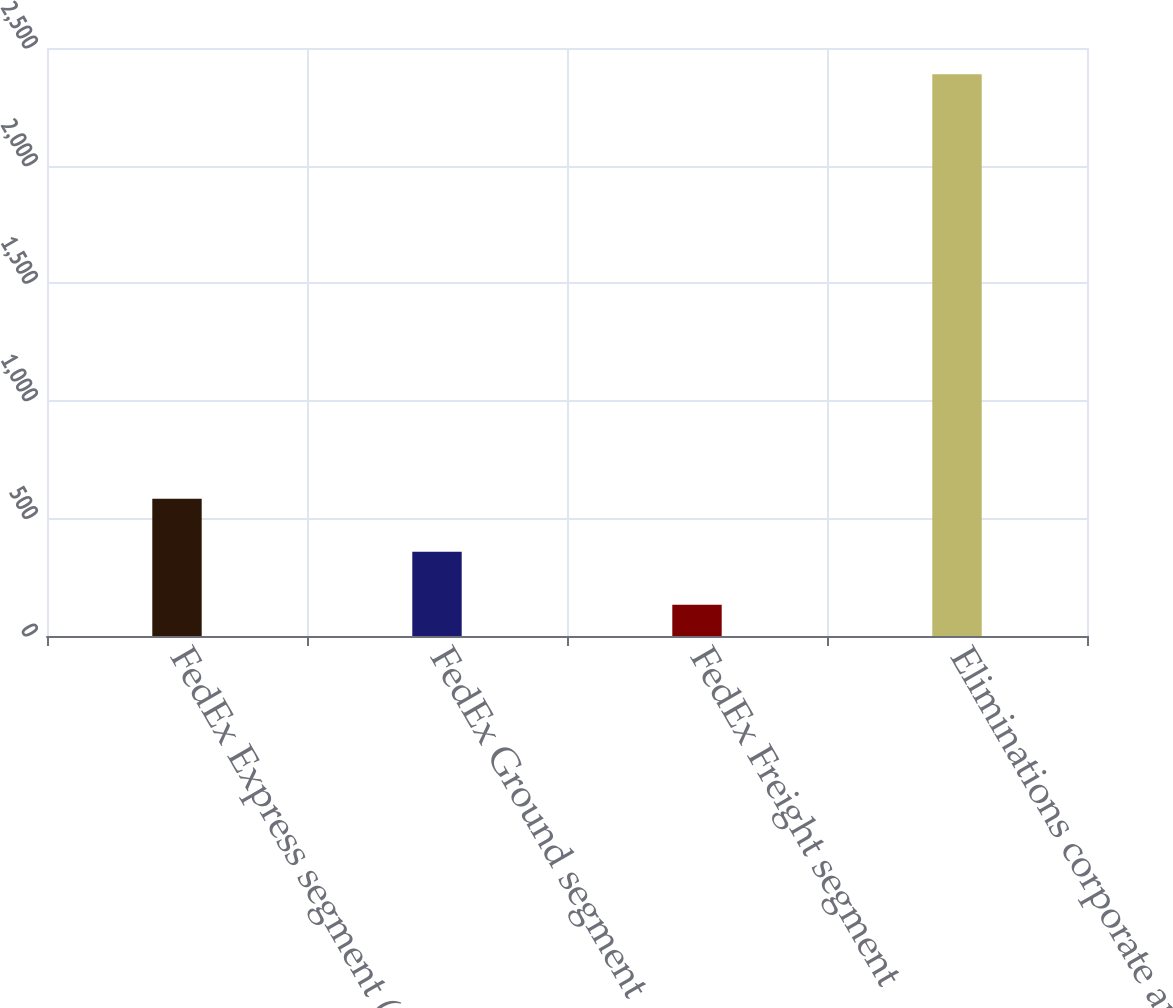<chart> <loc_0><loc_0><loc_500><loc_500><bar_chart><fcel>FedEx Express segment (1)<fcel>FedEx Ground segment<fcel>FedEx Freight segment<fcel>Eliminations corporate and<nl><fcel>584<fcel>358.5<fcel>133<fcel>2388<nl></chart> 